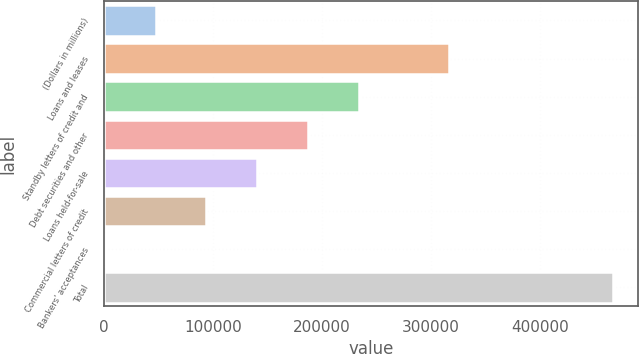<chart> <loc_0><loc_0><loc_500><loc_500><bar_chart><fcel>(Dollars in millions)<fcel>Loans and leases<fcel>Standby letters of credit and<fcel>Debt securities and other<fcel>Loans held-for-sale<fcel>Commercial letters of credit<fcel>Bankers' acceptances<fcel>Total<nl><fcel>47368.2<fcel>316816<fcel>233653<fcel>187082<fcel>140511<fcel>93939.4<fcel>797<fcel>466509<nl></chart> 